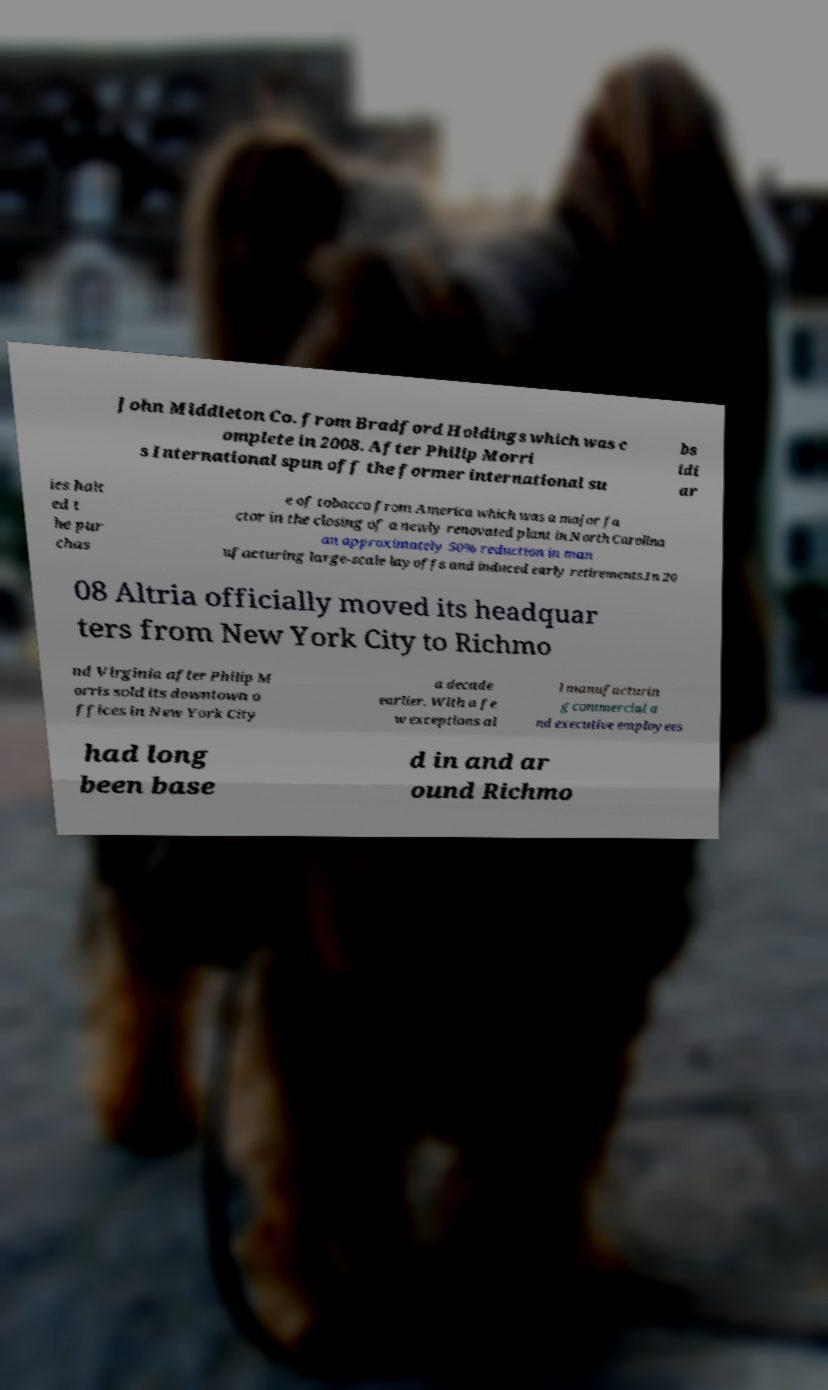Please read and relay the text visible in this image. What does it say? John Middleton Co. from Bradford Holdings which was c omplete in 2008. After Philip Morri s International spun off the former international su bs idi ar ies halt ed t he pur chas e of tobacco from America which was a major fa ctor in the closing of a newly renovated plant in North Carolina an approximately 50% reduction in man ufacturing large-scale layoffs and induced early retirements.In 20 08 Altria officially moved its headquar ters from New York City to Richmo nd Virginia after Philip M orris sold its downtown o ffices in New York City a decade earlier. With a fe w exceptions al l manufacturin g commercial a nd executive employees had long been base d in and ar ound Richmo 